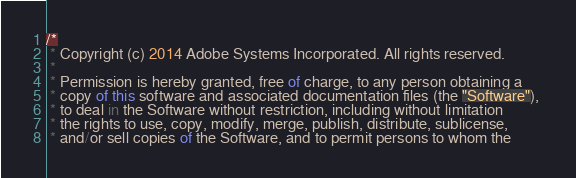<code> <loc_0><loc_0><loc_500><loc_500><_JavaScript_>/*
 * Copyright (c) 2014 Adobe Systems Incorporated. All rights reserved.
 *  
 * Permission is hereby granted, free of charge, to any person obtaining a
 * copy of this software and associated documentation files (the "Software"), 
 * to deal in the Software without restriction, including without limitation 
 * the rights to use, copy, modify, merge, publish, distribute, sublicense, 
 * and/or sell copies of the Software, and to permit persons to whom the </code> 